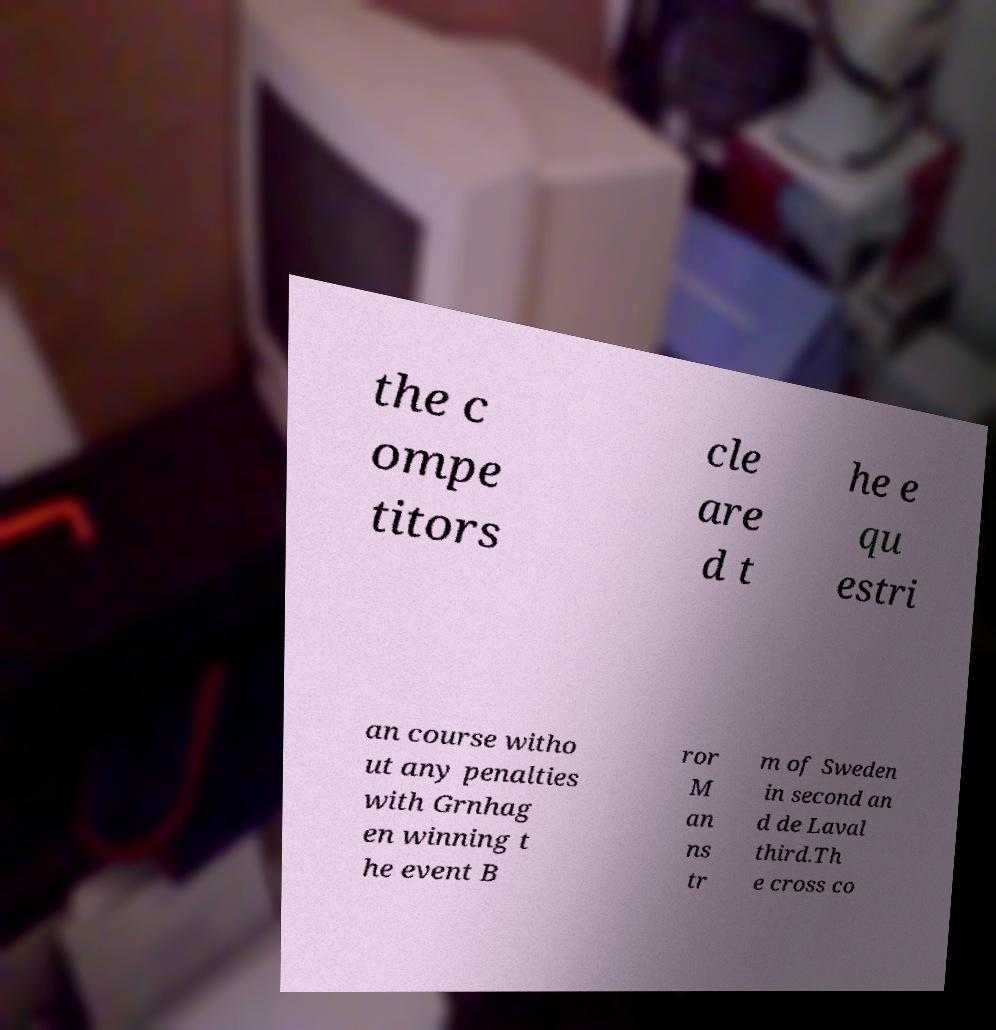What messages or text are displayed in this image? I need them in a readable, typed format. the c ompe titors cle are d t he e qu estri an course witho ut any penalties with Grnhag en winning t he event B ror M an ns tr m of Sweden in second an d de Laval third.Th e cross co 